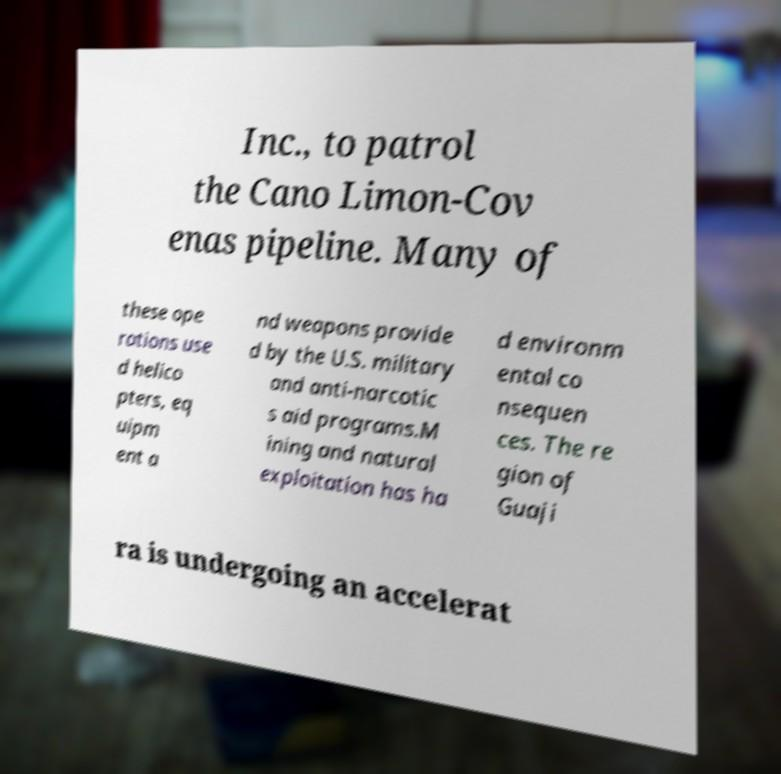Could you extract and type out the text from this image? Inc., to patrol the Cano Limon-Cov enas pipeline. Many of these ope rations use d helico pters, eq uipm ent a nd weapons provide d by the U.S. military and anti-narcotic s aid programs.M ining and natural exploitation has ha d environm ental co nsequen ces. The re gion of Guaji ra is undergoing an accelerat 